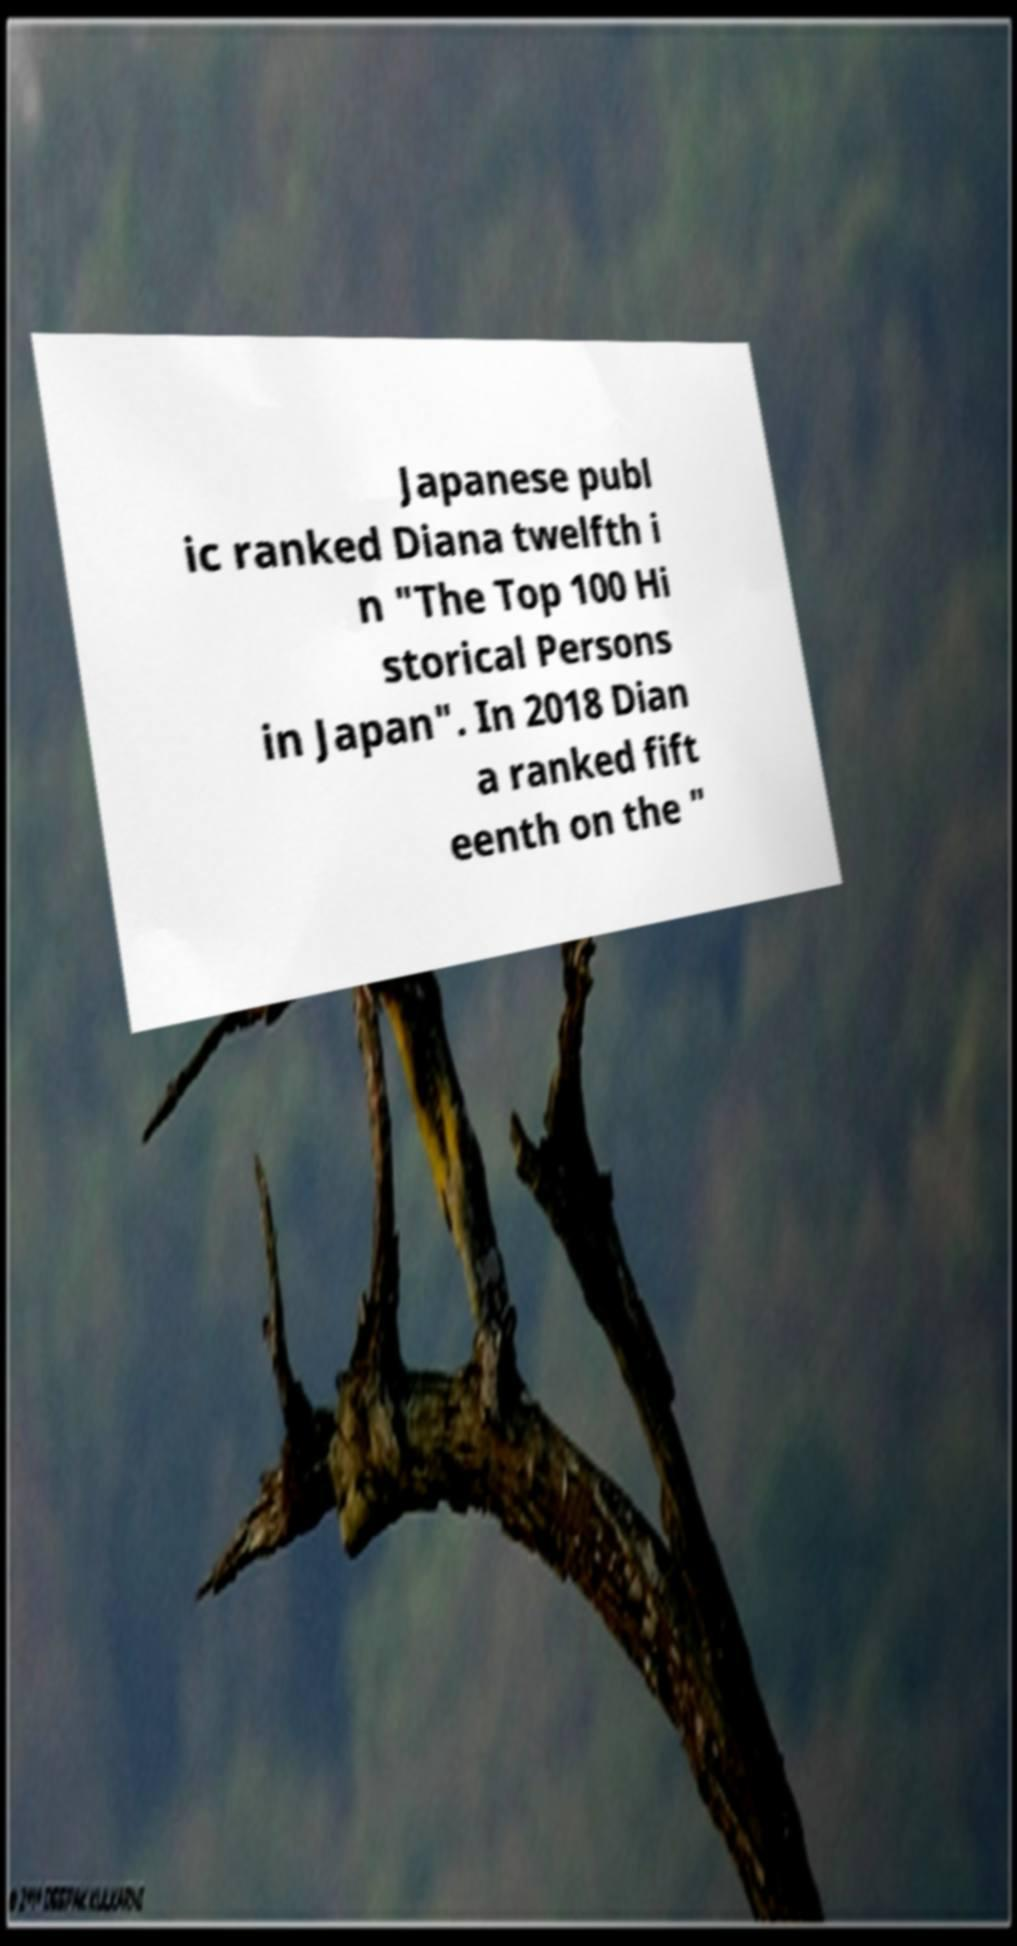For documentation purposes, I need the text within this image transcribed. Could you provide that? Japanese publ ic ranked Diana twelfth i n "The Top 100 Hi storical Persons in Japan". In 2018 Dian a ranked fift eenth on the " 